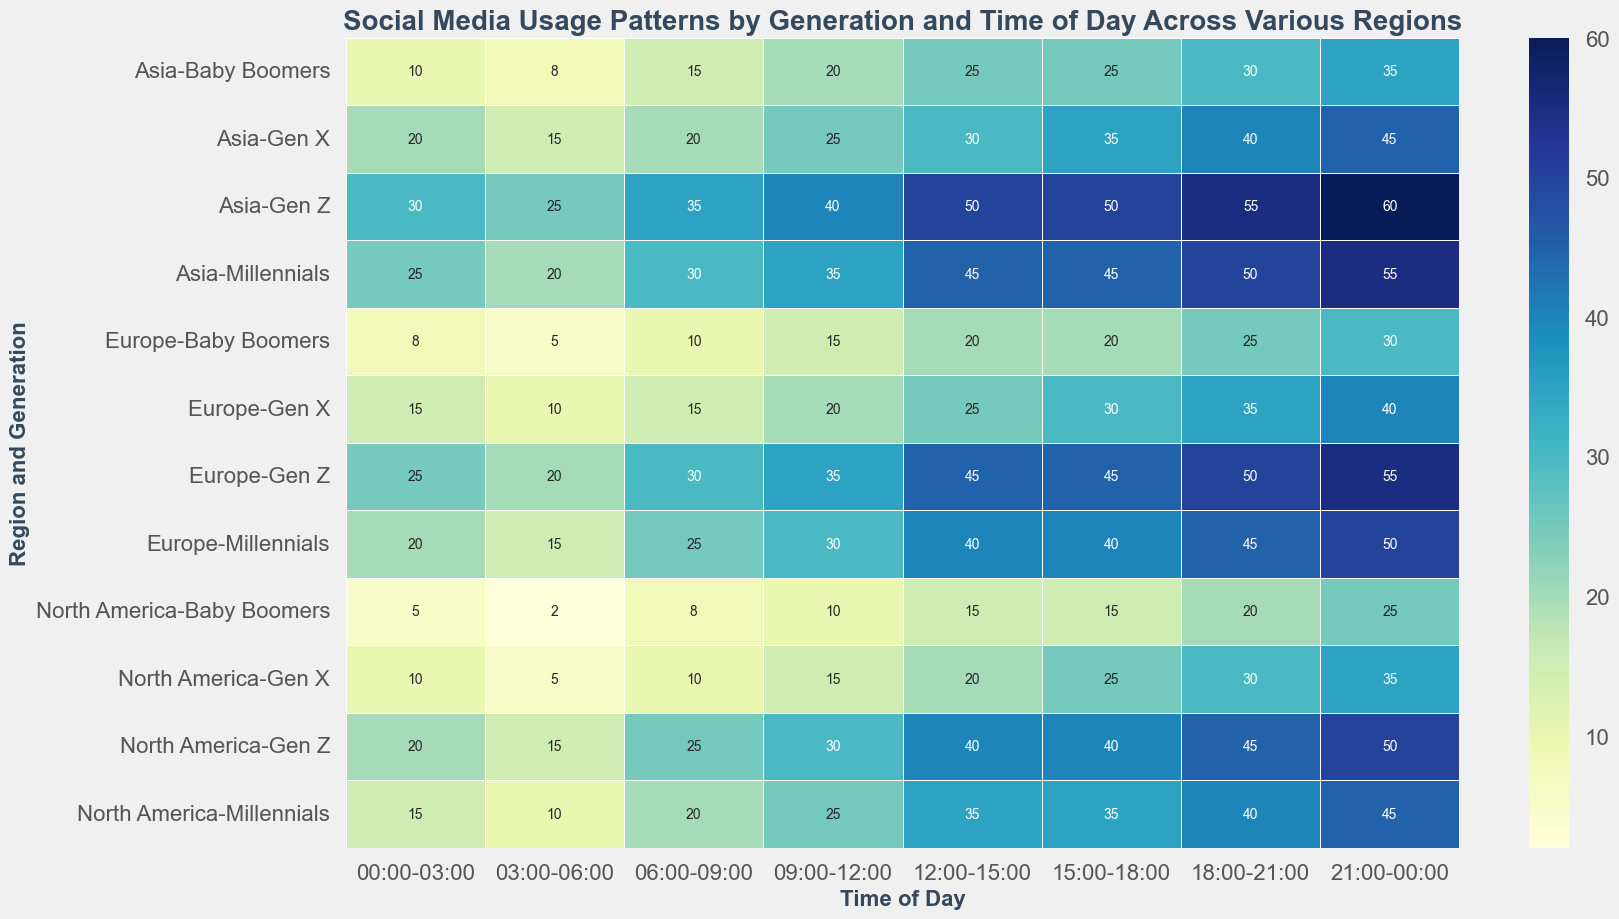What time of day has the highest social media usage percentage for Gen Z in Europe? To find out when Gen Z in Europe uses social media the most, look for the darkest cell in the row corresponding to Europe and Gen Z. The times are listed in columns. The time 21:00-00:00 has the darkest shade, which indicates the highest usage percentage.
Answer: 21:00-00:00 Between Millennials and Baby Boomers in North America, which generation uses social media more at 12:00-15:00? Compare the cells in the North America row for 12:00-15:00 between Millennials and Baby Boomers. The cell for Millennials is darker, indicating a higher usage percentage.
Answer: Millennials What is the difference in social media usage during 21:00-00:00 between Gen X in Asia and Gen X in North America? Find the cells corresponding to Gen X in Asia and North America at 21:00-00:00. The values are 45 for Asia and 35 for North America. The difference is 45 - 35.
Answer: 10 What is the average social media usage of Gen Z across all regions at 18:00-21:00? Look at the cells for Gen Z in North America, Europe, and Asia for 18:00-21:00. The values are 45, 50, and 55. Add them up and divide by 3 to find the average: (45 + 50 + 55)/3.
Answer: 50 Does Gen X in Asia use social media more or less than Gen X in Europe at 15:00-18:00? Compare the cells for Gen X in Asia and Europe at 15:00-18:00. The value for Asia is 35, and for Europe it is 30. Asia uses social media more.
Answer: More What is the total social media usage percentage for Baby Boomers in Europe during the entire day? Add up the values for Baby Boomers in Europe across all time intervals: 8, 5, 10, 15, 20, 20, 25, 30. The sum is 8 + 5 + 10 + 15 + 20 + 20 + 25 + 30.
Answer: 133 Which generation in North America uses social media the least at 03:00-06:00? Look at the cells for 03:00-06:00 for each generation in North America. The values are 15 for Gen Z, 10 for Millennials, 5 for Gen X, and 2 for Baby Boomers. Baby Boomers have the lowest value.
Answer: Baby Boomers How does the social media usage of Millennials at 12:00-15:00 compare across the three regions? Compare the shading and values for the cells at 12:00-15:00 for Millennials in North America, Europe, and Asia. The values are 35, 40, and 45, respectively. Usage increases from North America to Europe to Asia.
Answer: Increases from North America to Europe to Asia 